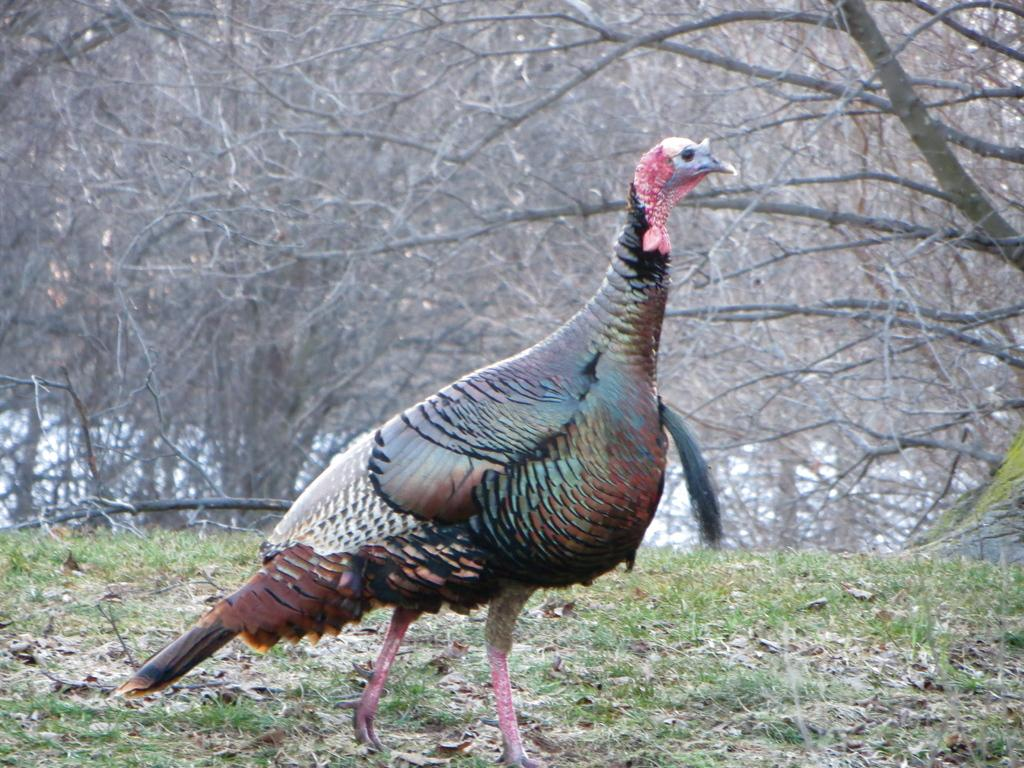What is the main subject in the middle of the image? A: There is a bird in the middle of the image. What can be seen in the background of the image? There are trees in the background of the image. What type of toothbrush is the bird using in the image? There is no toothbrush present in the image, and the bird is not using any such object. 